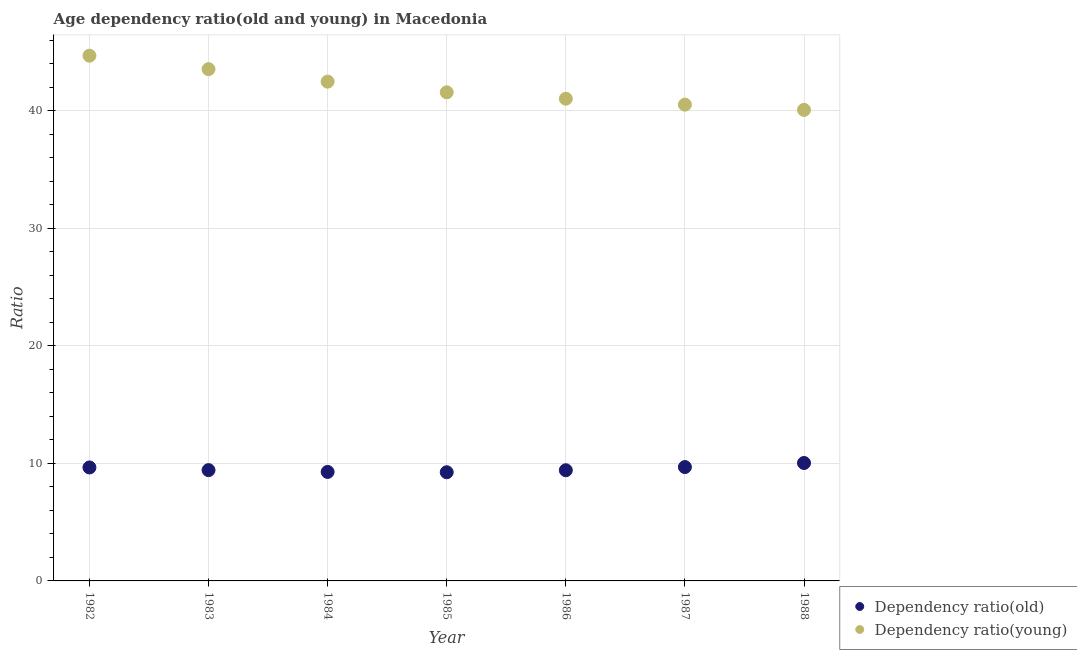How many different coloured dotlines are there?
Ensure brevity in your answer.  2. Is the number of dotlines equal to the number of legend labels?
Provide a short and direct response. Yes. What is the age dependency ratio(old) in 1988?
Give a very brief answer. 10.04. Across all years, what is the maximum age dependency ratio(old)?
Your answer should be compact. 10.04. Across all years, what is the minimum age dependency ratio(young)?
Provide a short and direct response. 40.09. In which year was the age dependency ratio(old) maximum?
Provide a short and direct response. 1988. What is the total age dependency ratio(old) in the graph?
Provide a short and direct response. 66.76. What is the difference between the age dependency ratio(old) in 1986 and that in 1987?
Give a very brief answer. -0.27. What is the difference between the age dependency ratio(young) in 1987 and the age dependency ratio(old) in 1986?
Your answer should be very brief. 31.12. What is the average age dependency ratio(young) per year?
Your answer should be very brief. 42. In the year 1986, what is the difference between the age dependency ratio(old) and age dependency ratio(young)?
Your answer should be compact. -31.62. What is the ratio of the age dependency ratio(old) in 1983 to that in 1986?
Keep it short and to the point. 1. Is the age dependency ratio(young) in 1985 less than that in 1987?
Ensure brevity in your answer.  No. Is the difference between the age dependency ratio(old) in 1984 and 1986 greater than the difference between the age dependency ratio(young) in 1984 and 1986?
Your answer should be very brief. No. What is the difference between the highest and the second highest age dependency ratio(old)?
Give a very brief answer. 0.35. What is the difference between the highest and the lowest age dependency ratio(young)?
Provide a succinct answer. 4.61. Is the age dependency ratio(young) strictly less than the age dependency ratio(old) over the years?
Make the answer very short. No. How many dotlines are there?
Offer a terse response. 2. What is the difference between two consecutive major ticks on the Y-axis?
Keep it short and to the point. 10. Are the values on the major ticks of Y-axis written in scientific E-notation?
Offer a very short reply. No. Does the graph contain any zero values?
Offer a terse response. No. Where does the legend appear in the graph?
Keep it short and to the point. Bottom right. What is the title of the graph?
Make the answer very short. Age dependency ratio(old and young) in Macedonia. Does "Taxes" appear as one of the legend labels in the graph?
Ensure brevity in your answer.  No. What is the label or title of the X-axis?
Ensure brevity in your answer.  Year. What is the label or title of the Y-axis?
Your response must be concise. Ratio. What is the Ratio in Dependency ratio(old) in 1982?
Keep it short and to the point. 9.66. What is the Ratio in Dependency ratio(young) in 1982?
Your answer should be compact. 44.7. What is the Ratio of Dependency ratio(old) in 1983?
Your response must be concise. 9.43. What is the Ratio of Dependency ratio(young) in 1983?
Give a very brief answer. 43.56. What is the Ratio in Dependency ratio(old) in 1984?
Your answer should be compact. 9.28. What is the Ratio of Dependency ratio(young) in 1984?
Keep it short and to the point. 42.49. What is the Ratio in Dependency ratio(old) in 1985?
Make the answer very short. 9.25. What is the Ratio in Dependency ratio(young) in 1985?
Ensure brevity in your answer.  41.59. What is the Ratio in Dependency ratio(old) in 1986?
Keep it short and to the point. 9.42. What is the Ratio of Dependency ratio(young) in 1986?
Offer a very short reply. 41.04. What is the Ratio in Dependency ratio(old) in 1987?
Offer a very short reply. 9.69. What is the Ratio in Dependency ratio(young) in 1987?
Offer a terse response. 40.54. What is the Ratio of Dependency ratio(old) in 1988?
Provide a succinct answer. 10.04. What is the Ratio in Dependency ratio(young) in 1988?
Offer a very short reply. 40.09. Across all years, what is the maximum Ratio of Dependency ratio(old)?
Your answer should be very brief. 10.04. Across all years, what is the maximum Ratio of Dependency ratio(young)?
Provide a short and direct response. 44.7. Across all years, what is the minimum Ratio of Dependency ratio(old)?
Give a very brief answer. 9.25. Across all years, what is the minimum Ratio in Dependency ratio(young)?
Provide a short and direct response. 40.09. What is the total Ratio of Dependency ratio(old) in the graph?
Provide a succinct answer. 66.76. What is the total Ratio in Dependency ratio(young) in the graph?
Your answer should be compact. 294.01. What is the difference between the Ratio in Dependency ratio(old) in 1982 and that in 1983?
Your response must be concise. 0.23. What is the difference between the Ratio in Dependency ratio(young) in 1982 and that in 1983?
Provide a short and direct response. 1.14. What is the difference between the Ratio in Dependency ratio(old) in 1982 and that in 1984?
Ensure brevity in your answer.  0.38. What is the difference between the Ratio of Dependency ratio(young) in 1982 and that in 1984?
Make the answer very short. 2.21. What is the difference between the Ratio of Dependency ratio(old) in 1982 and that in 1985?
Give a very brief answer. 0.41. What is the difference between the Ratio of Dependency ratio(young) in 1982 and that in 1985?
Offer a terse response. 3.12. What is the difference between the Ratio in Dependency ratio(old) in 1982 and that in 1986?
Provide a short and direct response. 0.24. What is the difference between the Ratio in Dependency ratio(young) in 1982 and that in 1986?
Offer a very short reply. 3.66. What is the difference between the Ratio of Dependency ratio(old) in 1982 and that in 1987?
Make the answer very short. -0.03. What is the difference between the Ratio of Dependency ratio(young) in 1982 and that in 1987?
Give a very brief answer. 4.16. What is the difference between the Ratio of Dependency ratio(old) in 1982 and that in 1988?
Provide a succinct answer. -0.38. What is the difference between the Ratio of Dependency ratio(young) in 1982 and that in 1988?
Provide a succinct answer. 4.61. What is the difference between the Ratio of Dependency ratio(old) in 1983 and that in 1984?
Ensure brevity in your answer.  0.15. What is the difference between the Ratio in Dependency ratio(young) in 1983 and that in 1984?
Give a very brief answer. 1.06. What is the difference between the Ratio in Dependency ratio(old) in 1983 and that in 1985?
Ensure brevity in your answer.  0.18. What is the difference between the Ratio of Dependency ratio(young) in 1983 and that in 1985?
Provide a short and direct response. 1.97. What is the difference between the Ratio in Dependency ratio(old) in 1983 and that in 1986?
Your answer should be compact. 0.01. What is the difference between the Ratio of Dependency ratio(young) in 1983 and that in 1986?
Your response must be concise. 2.52. What is the difference between the Ratio in Dependency ratio(old) in 1983 and that in 1987?
Provide a succinct answer. -0.26. What is the difference between the Ratio in Dependency ratio(young) in 1983 and that in 1987?
Your answer should be very brief. 3.02. What is the difference between the Ratio in Dependency ratio(old) in 1983 and that in 1988?
Provide a short and direct response. -0.61. What is the difference between the Ratio of Dependency ratio(young) in 1983 and that in 1988?
Offer a very short reply. 3.47. What is the difference between the Ratio of Dependency ratio(old) in 1984 and that in 1985?
Provide a short and direct response. 0.03. What is the difference between the Ratio in Dependency ratio(old) in 1984 and that in 1986?
Keep it short and to the point. -0.14. What is the difference between the Ratio in Dependency ratio(young) in 1984 and that in 1986?
Provide a short and direct response. 1.45. What is the difference between the Ratio of Dependency ratio(old) in 1984 and that in 1987?
Your answer should be very brief. -0.42. What is the difference between the Ratio of Dependency ratio(young) in 1984 and that in 1987?
Give a very brief answer. 1.96. What is the difference between the Ratio in Dependency ratio(old) in 1984 and that in 1988?
Your response must be concise. -0.76. What is the difference between the Ratio in Dependency ratio(young) in 1984 and that in 1988?
Offer a very short reply. 2.4. What is the difference between the Ratio in Dependency ratio(old) in 1985 and that in 1986?
Make the answer very short. -0.17. What is the difference between the Ratio of Dependency ratio(young) in 1985 and that in 1986?
Your answer should be very brief. 0.55. What is the difference between the Ratio in Dependency ratio(old) in 1985 and that in 1987?
Ensure brevity in your answer.  -0.44. What is the difference between the Ratio of Dependency ratio(young) in 1985 and that in 1987?
Give a very brief answer. 1.05. What is the difference between the Ratio of Dependency ratio(old) in 1985 and that in 1988?
Ensure brevity in your answer.  -0.79. What is the difference between the Ratio in Dependency ratio(young) in 1985 and that in 1988?
Make the answer very short. 1.49. What is the difference between the Ratio of Dependency ratio(old) in 1986 and that in 1987?
Make the answer very short. -0.27. What is the difference between the Ratio in Dependency ratio(young) in 1986 and that in 1987?
Ensure brevity in your answer.  0.5. What is the difference between the Ratio in Dependency ratio(old) in 1986 and that in 1988?
Offer a terse response. -0.62. What is the difference between the Ratio in Dependency ratio(young) in 1986 and that in 1988?
Your answer should be very brief. 0.95. What is the difference between the Ratio of Dependency ratio(old) in 1987 and that in 1988?
Offer a very short reply. -0.35. What is the difference between the Ratio of Dependency ratio(young) in 1987 and that in 1988?
Keep it short and to the point. 0.45. What is the difference between the Ratio of Dependency ratio(old) in 1982 and the Ratio of Dependency ratio(young) in 1983?
Offer a very short reply. -33.9. What is the difference between the Ratio of Dependency ratio(old) in 1982 and the Ratio of Dependency ratio(young) in 1984?
Your answer should be compact. -32.84. What is the difference between the Ratio of Dependency ratio(old) in 1982 and the Ratio of Dependency ratio(young) in 1985?
Your answer should be compact. -31.93. What is the difference between the Ratio in Dependency ratio(old) in 1982 and the Ratio in Dependency ratio(young) in 1986?
Give a very brief answer. -31.38. What is the difference between the Ratio of Dependency ratio(old) in 1982 and the Ratio of Dependency ratio(young) in 1987?
Give a very brief answer. -30.88. What is the difference between the Ratio of Dependency ratio(old) in 1982 and the Ratio of Dependency ratio(young) in 1988?
Offer a very short reply. -30.43. What is the difference between the Ratio of Dependency ratio(old) in 1983 and the Ratio of Dependency ratio(young) in 1984?
Your answer should be compact. -33.06. What is the difference between the Ratio of Dependency ratio(old) in 1983 and the Ratio of Dependency ratio(young) in 1985?
Provide a succinct answer. -32.15. What is the difference between the Ratio of Dependency ratio(old) in 1983 and the Ratio of Dependency ratio(young) in 1986?
Offer a very short reply. -31.61. What is the difference between the Ratio of Dependency ratio(old) in 1983 and the Ratio of Dependency ratio(young) in 1987?
Provide a succinct answer. -31.11. What is the difference between the Ratio of Dependency ratio(old) in 1983 and the Ratio of Dependency ratio(young) in 1988?
Keep it short and to the point. -30.66. What is the difference between the Ratio in Dependency ratio(old) in 1984 and the Ratio in Dependency ratio(young) in 1985?
Ensure brevity in your answer.  -32.31. What is the difference between the Ratio in Dependency ratio(old) in 1984 and the Ratio in Dependency ratio(young) in 1986?
Offer a terse response. -31.76. What is the difference between the Ratio in Dependency ratio(old) in 1984 and the Ratio in Dependency ratio(young) in 1987?
Your response must be concise. -31.26. What is the difference between the Ratio in Dependency ratio(old) in 1984 and the Ratio in Dependency ratio(young) in 1988?
Make the answer very short. -30.81. What is the difference between the Ratio of Dependency ratio(old) in 1985 and the Ratio of Dependency ratio(young) in 1986?
Provide a short and direct response. -31.79. What is the difference between the Ratio of Dependency ratio(old) in 1985 and the Ratio of Dependency ratio(young) in 1987?
Provide a succinct answer. -31.29. What is the difference between the Ratio in Dependency ratio(old) in 1985 and the Ratio in Dependency ratio(young) in 1988?
Ensure brevity in your answer.  -30.84. What is the difference between the Ratio of Dependency ratio(old) in 1986 and the Ratio of Dependency ratio(young) in 1987?
Your answer should be very brief. -31.12. What is the difference between the Ratio of Dependency ratio(old) in 1986 and the Ratio of Dependency ratio(young) in 1988?
Your answer should be very brief. -30.67. What is the difference between the Ratio of Dependency ratio(old) in 1987 and the Ratio of Dependency ratio(young) in 1988?
Provide a short and direct response. -30.4. What is the average Ratio of Dependency ratio(old) per year?
Offer a terse response. 9.54. What is the average Ratio of Dependency ratio(young) per year?
Provide a succinct answer. 42. In the year 1982, what is the difference between the Ratio in Dependency ratio(old) and Ratio in Dependency ratio(young)?
Your answer should be compact. -35.04. In the year 1983, what is the difference between the Ratio of Dependency ratio(old) and Ratio of Dependency ratio(young)?
Your answer should be compact. -34.13. In the year 1984, what is the difference between the Ratio of Dependency ratio(old) and Ratio of Dependency ratio(young)?
Your answer should be very brief. -33.22. In the year 1985, what is the difference between the Ratio in Dependency ratio(old) and Ratio in Dependency ratio(young)?
Ensure brevity in your answer.  -32.34. In the year 1986, what is the difference between the Ratio of Dependency ratio(old) and Ratio of Dependency ratio(young)?
Your response must be concise. -31.62. In the year 1987, what is the difference between the Ratio in Dependency ratio(old) and Ratio in Dependency ratio(young)?
Ensure brevity in your answer.  -30.85. In the year 1988, what is the difference between the Ratio in Dependency ratio(old) and Ratio in Dependency ratio(young)?
Make the answer very short. -30.05. What is the ratio of the Ratio in Dependency ratio(young) in 1982 to that in 1983?
Your answer should be very brief. 1.03. What is the ratio of the Ratio of Dependency ratio(old) in 1982 to that in 1984?
Ensure brevity in your answer.  1.04. What is the ratio of the Ratio of Dependency ratio(young) in 1982 to that in 1984?
Your response must be concise. 1.05. What is the ratio of the Ratio of Dependency ratio(old) in 1982 to that in 1985?
Provide a short and direct response. 1.04. What is the ratio of the Ratio of Dependency ratio(young) in 1982 to that in 1985?
Ensure brevity in your answer.  1.07. What is the ratio of the Ratio of Dependency ratio(old) in 1982 to that in 1986?
Keep it short and to the point. 1.03. What is the ratio of the Ratio in Dependency ratio(young) in 1982 to that in 1986?
Keep it short and to the point. 1.09. What is the ratio of the Ratio of Dependency ratio(old) in 1982 to that in 1987?
Your answer should be very brief. 1. What is the ratio of the Ratio of Dependency ratio(young) in 1982 to that in 1987?
Keep it short and to the point. 1.1. What is the ratio of the Ratio of Dependency ratio(old) in 1982 to that in 1988?
Your response must be concise. 0.96. What is the ratio of the Ratio in Dependency ratio(young) in 1982 to that in 1988?
Give a very brief answer. 1.11. What is the ratio of the Ratio in Dependency ratio(old) in 1983 to that in 1984?
Ensure brevity in your answer.  1.02. What is the ratio of the Ratio of Dependency ratio(old) in 1983 to that in 1985?
Provide a succinct answer. 1.02. What is the ratio of the Ratio of Dependency ratio(young) in 1983 to that in 1985?
Offer a terse response. 1.05. What is the ratio of the Ratio of Dependency ratio(young) in 1983 to that in 1986?
Provide a succinct answer. 1.06. What is the ratio of the Ratio of Dependency ratio(old) in 1983 to that in 1987?
Provide a short and direct response. 0.97. What is the ratio of the Ratio in Dependency ratio(young) in 1983 to that in 1987?
Your answer should be compact. 1.07. What is the ratio of the Ratio of Dependency ratio(old) in 1983 to that in 1988?
Your answer should be very brief. 0.94. What is the ratio of the Ratio in Dependency ratio(young) in 1983 to that in 1988?
Your answer should be compact. 1.09. What is the ratio of the Ratio in Dependency ratio(young) in 1984 to that in 1985?
Your answer should be very brief. 1.02. What is the ratio of the Ratio in Dependency ratio(old) in 1984 to that in 1986?
Make the answer very short. 0.98. What is the ratio of the Ratio of Dependency ratio(young) in 1984 to that in 1986?
Your answer should be compact. 1.04. What is the ratio of the Ratio of Dependency ratio(old) in 1984 to that in 1987?
Your answer should be very brief. 0.96. What is the ratio of the Ratio of Dependency ratio(young) in 1984 to that in 1987?
Offer a very short reply. 1.05. What is the ratio of the Ratio of Dependency ratio(old) in 1984 to that in 1988?
Offer a very short reply. 0.92. What is the ratio of the Ratio of Dependency ratio(young) in 1984 to that in 1988?
Keep it short and to the point. 1.06. What is the ratio of the Ratio in Dependency ratio(old) in 1985 to that in 1986?
Keep it short and to the point. 0.98. What is the ratio of the Ratio of Dependency ratio(young) in 1985 to that in 1986?
Provide a succinct answer. 1.01. What is the ratio of the Ratio of Dependency ratio(old) in 1985 to that in 1987?
Provide a short and direct response. 0.95. What is the ratio of the Ratio of Dependency ratio(young) in 1985 to that in 1987?
Keep it short and to the point. 1.03. What is the ratio of the Ratio of Dependency ratio(old) in 1985 to that in 1988?
Your response must be concise. 0.92. What is the ratio of the Ratio in Dependency ratio(young) in 1985 to that in 1988?
Make the answer very short. 1.04. What is the ratio of the Ratio in Dependency ratio(old) in 1986 to that in 1987?
Ensure brevity in your answer.  0.97. What is the ratio of the Ratio of Dependency ratio(young) in 1986 to that in 1987?
Make the answer very short. 1.01. What is the ratio of the Ratio in Dependency ratio(old) in 1986 to that in 1988?
Make the answer very short. 0.94. What is the ratio of the Ratio in Dependency ratio(young) in 1986 to that in 1988?
Provide a short and direct response. 1.02. What is the ratio of the Ratio in Dependency ratio(old) in 1987 to that in 1988?
Your response must be concise. 0.97. What is the ratio of the Ratio in Dependency ratio(young) in 1987 to that in 1988?
Your answer should be compact. 1.01. What is the difference between the highest and the second highest Ratio in Dependency ratio(old)?
Ensure brevity in your answer.  0.35. What is the difference between the highest and the second highest Ratio of Dependency ratio(young)?
Make the answer very short. 1.14. What is the difference between the highest and the lowest Ratio in Dependency ratio(old)?
Provide a short and direct response. 0.79. What is the difference between the highest and the lowest Ratio of Dependency ratio(young)?
Provide a succinct answer. 4.61. 